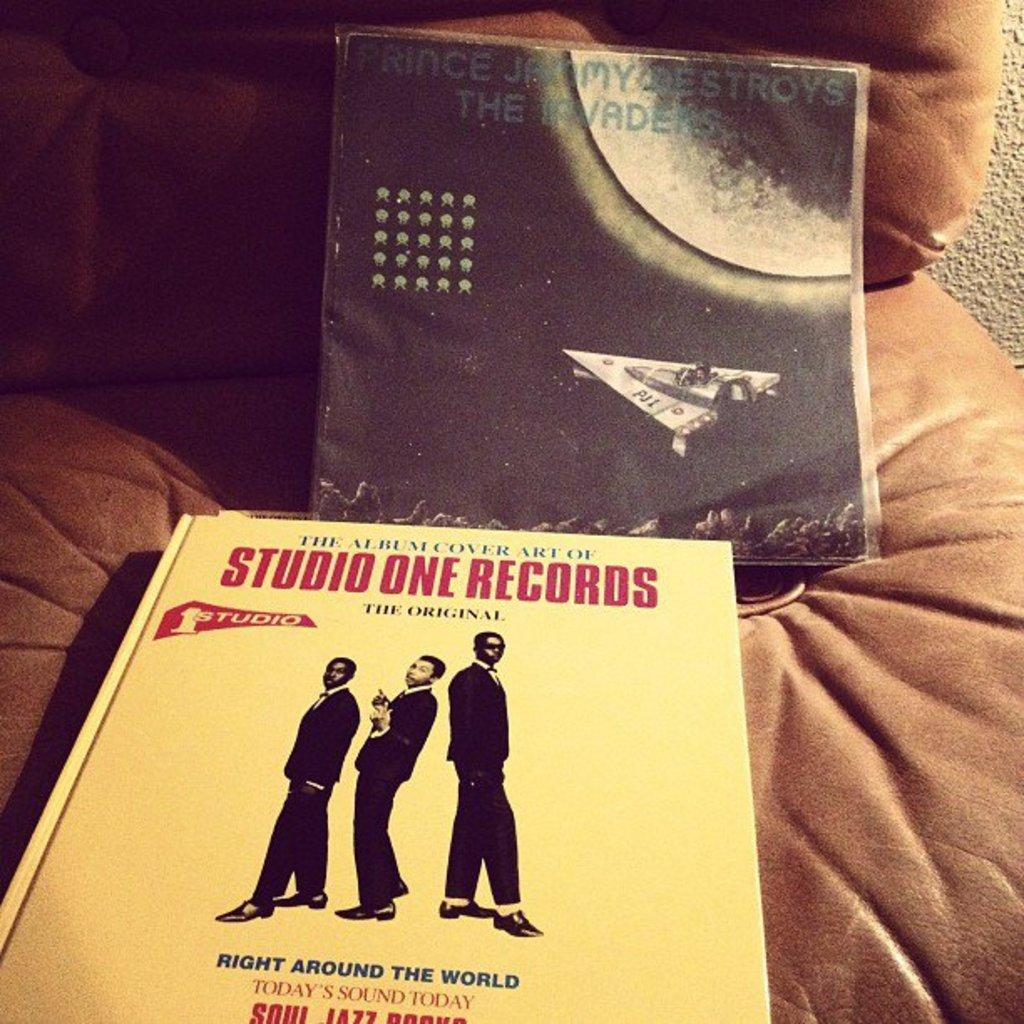Provide a one-sentence caption for the provided image. A book from Studio One Records sits on a brown leather sofa. 